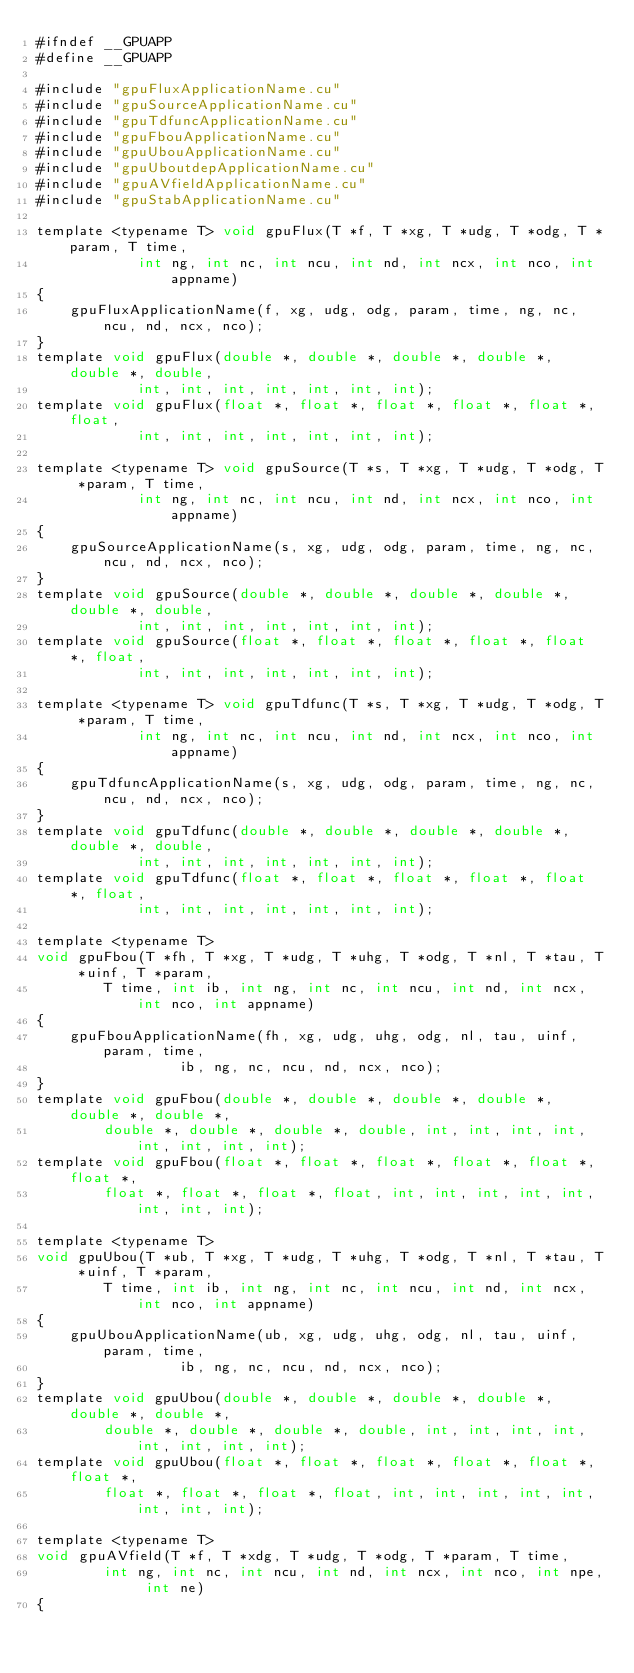<code> <loc_0><loc_0><loc_500><loc_500><_Cuda_>#ifndef __GPUAPP
#define __GPUAPP

#include "gpuFluxApplicationName.cu"
#include "gpuSourceApplicationName.cu"
#include "gpuTdfuncApplicationName.cu"
#include "gpuFbouApplicationName.cu"
#include "gpuUbouApplicationName.cu"
#include "gpuUboutdepApplicationName.cu"
#include "gpuAVfieldApplicationName.cu"
#include "gpuStabApplicationName.cu"

template <typename T> void gpuFlux(T *f, T *xg, T *udg, T *odg, T *param, T time, 
            int ng, int nc, int ncu, int nd, int ncx, int nco, int appname)
{            
    gpuFluxApplicationName(f, xg, udg, odg, param, time, ng, nc, ncu, nd, ncx, nco);        
}
template void gpuFlux(double *, double *, double *, double *, double *, double, 
            int, int, int, int, int, int, int);
template void gpuFlux(float *, float *, float *, float *, float *, float, 
            int, int, int, int, int, int, int);

template <typename T> void gpuSource(T *s, T *xg, T *udg, T *odg, T *param, T time, 
            int ng, int nc, int ncu, int nd, int ncx, int nco, int appname)
{        
    gpuSourceApplicationName(s, xg, udg, odg, param, time, ng, nc, ncu, nd, ncx, nco);   
}
template void gpuSource(double *, double *, double *, double *, double *, double, 
            int, int, int, int, int, int, int);
template void gpuSource(float *, float *, float *, float *, float *, float, 
            int, int, int, int, int, int, int);

template <typename T> void gpuTdfunc(T *s, T *xg, T *udg, T *odg, T *param, T time, 
            int ng, int nc, int ncu, int nd, int ncx, int nco, int appname)
{        
    gpuTdfuncApplicationName(s, xg, udg, odg, param, time, ng, nc, ncu, nd, ncx, nco);   
}
template void gpuTdfunc(double *, double *, double *, double *, double *, double, 
            int, int, int, int, int, int, int);
template void gpuTdfunc(float *, float *, float *, float *, float *, float, 
            int, int, int, int, int, int, int);

template <typename T>   
void gpuFbou(T *fh, T *xg, T *udg, T *uhg, T *odg, T *nl, T *tau, T *uinf, T *param, 
        T time, int ib, int ng, int nc, int ncu, int nd, int ncx, int nco, int appname)
{        
    gpuFbouApplicationName(fh, xg, udg, uhg, odg, nl, tau, uinf, param, time, 
                 ib, ng, nc, ncu, nd, ncx, nco);
}
template void gpuFbou(double *, double *, double *, double *, double *, double *, 
        double *, double *, double *, double, int, int, int, int, int, int, int, int);
template void gpuFbou(float *, float *, float *, float *, float *, float *, 
        float *, float *, float *, float, int, int, int, int, int, int, int, int);

template <typename T>   
void gpuUbou(T *ub, T *xg, T *udg, T *uhg, T *odg, T *nl, T *tau, T *uinf, T *param, 
        T time, int ib, int ng, int nc, int ncu, int nd, int ncx, int nco, int appname)
{        
    gpuUbouApplicationName(ub, xg, udg, uhg, odg, nl, tau, uinf, param, time, 
                 ib, ng, nc, ncu, nd, ncx, nco);
}
template void gpuUbou(double *, double *, double *, double *, double *, double *, 
        double *, double *, double *, double, int, int, int, int, int, int, int, int);
template void gpuUbou(float *, float *, float *, float *, float *, float *, 
        float *, float *, float *, float, int, int, int, int, int, int, int, int);

template <typename T> 
void gpuAVfield(T *f, T *xdg, T *udg, T *odg, T *param, T time, 
        int ng, int nc, int ncu, int nd, int ncx, int nco, int npe, int ne)
{</code> 